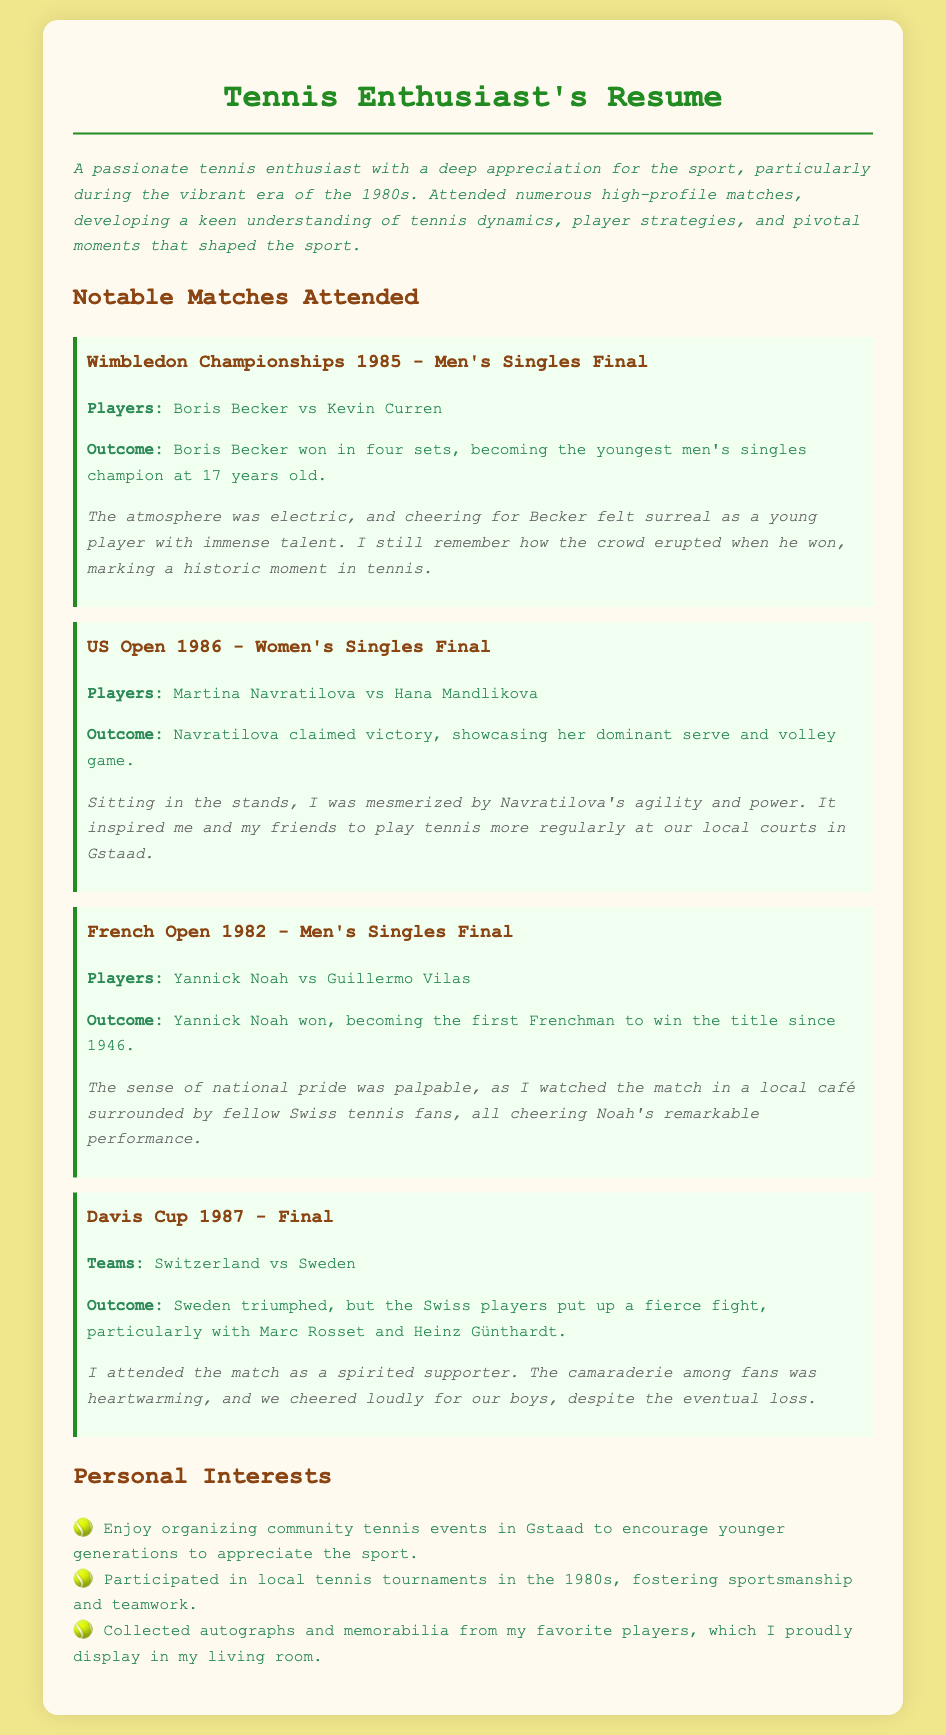What year did Boris Becker win Wimbledon? The document states that Boris Becker won Wimbledon in 1985.
Answer: 1985 Who won the US Open Women's Singles Final in 1986? The document mentions Martina Navratilova as the winner of the US Open Women's Singles Final in 1986.
Answer: Martina Navratilova What was unique about Yannick Noah's French Open win in 1982? The document indicates that Yannick Noah became the first Frenchman to win the title since 1946.
Answer: First Frenchman since 1946 Which teams competed in the 1987 Davis Cup Final? The document lists Switzerland and Sweden as the competing teams in the 1987 Davis Cup Final.
Answer: Switzerland vs Sweden What was a personal interest mentioned in the resume? The resume includes organizing community tennis events in Gstaad as a personal interest.
Answer: Organizing community tennis events How did the atmosphere change between wins and losses in the matches attended? The highlights suggest a sense of pride and excitement during wins, contrasting with a supportive camaraderie during losses, especially noted in the Davis Cup.
Answer: Pride and excitement vs supportive camaraderie What is the primary focus of the tennis enthusiast's recollections? The document highlights the significant matches of the 1980s as the primary focus of the enthusiast's recollections.
Answer: Significant matches of the 1980s Which event inspired the enthusiast and friends to play tennis more regularly? The US Open 1986 match featuring Martina Navratilova inspired the enthusiast and friends to play tennis more often.
Answer: US Open 1986 